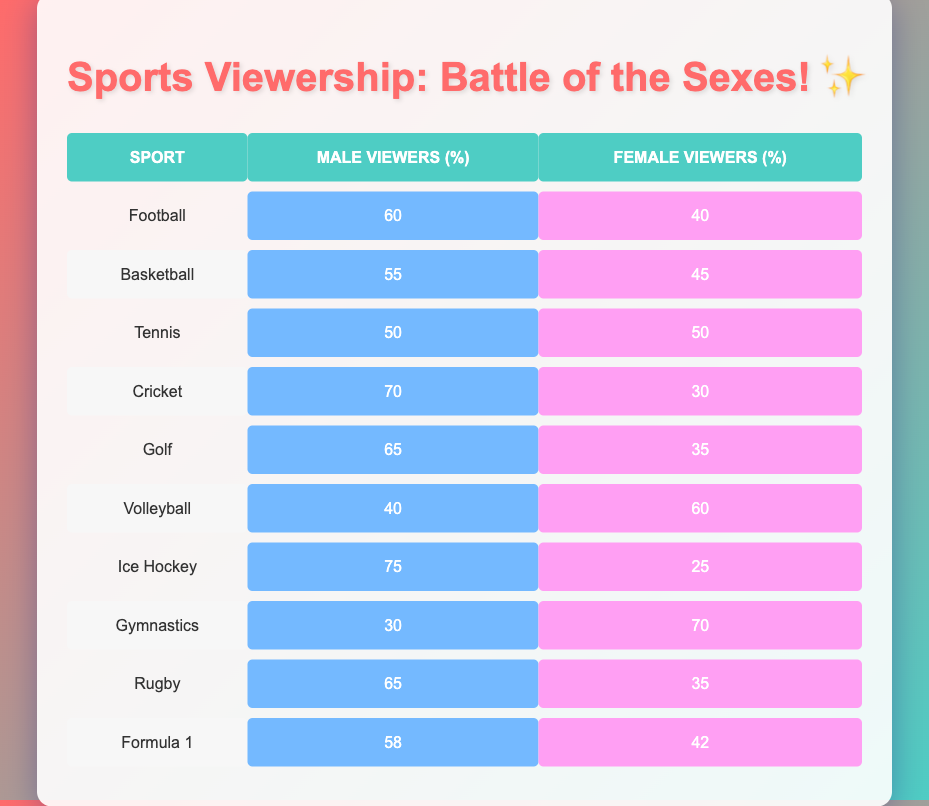What's the percentage of male viewers for Football? The table shows that the percentage of male viewers for Football is listed under the Male Viewers (%) column for Football, which is 60%.
Answer: 60% Which sport has the highest percentage of female viewers? By comparing the Female Viewers (%) column, Volleyball shows a high percentage of 60%, which is greater than the percentages for all other sports listed.
Answer: Volleyball What is the difference in male viewership between Ice Hockey and Cricket? The percentage of male viewers for Ice Hockey is 75% and for Cricket is 70%. The difference is calculated as (75 - 70) = 5%.
Answer: 5% Are the male viewers and female viewers for Tennis equal? The table indicates that both male and female viewers for Tennis are 50%, confirming that they are indeed equal.
Answer: Yes For which sport does the percentage of male viewers drop below 50%? Reviewing the table, the only sport where male viewers are below 50% is Gymnastics, which has a male percentage of 30%.
Answer: Gymnastics What is the average percentage of male viewers across all sports? To find the average, sum all male percentages (60 + 55 + 50 + 70 + 65 + 40 + 75 + 30 + 65 + 58 =  75). There are 10 data points, so the average is calculated as  61% by dividing the total by 10.
Answer: 61% If you were to combine the male percentages for Soccer, Basketball, and Golf, what would that total be? Combining these percentages: 60 (Football) + 55 (Basketball) + 65 (Golf) totals to 180%. The cumulative percentage for these three sports is thus calculated to be 180%.
Answer: 180% Which sport has the smallest male viewer percentage? The lowest male viewer percentage is found under Gymnastics, which is 30% as observed in the Male Viewers (%) column.
Answer: Gymnastics Is the percentage of male viewers for Rugby greater than that for Formula 1? The table reveals Rugby has 65% male viewers, while Formula 1 has 58%. Since 65 is greater than 58, the answer is yes.
Answer: Yes 